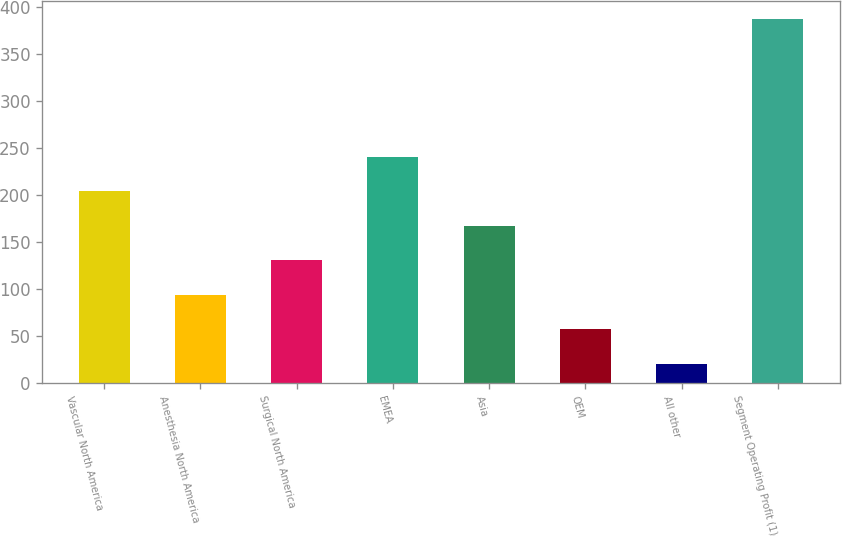Convert chart to OTSL. <chart><loc_0><loc_0><loc_500><loc_500><bar_chart><fcel>Vascular North America<fcel>Anesthesia North America<fcel>Surgical North America<fcel>EMEA<fcel>Asia<fcel>OEM<fcel>All other<fcel>Segment Operating Profit (1)<nl><fcel>204.15<fcel>93.9<fcel>130.65<fcel>240.9<fcel>167.4<fcel>57.15<fcel>20.4<fcel>387.9<nl></chart> 